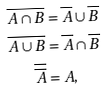<formula> <loc_0><loc_0><loc_500><loc_500>\overline { A \cap B } & = \overline { A } \cup \overline { B } \\ \overline { A \cup B } & = \overline { A } \cap \overline { B } \\ \overline { \overline { A } } & = A ,</formula> 